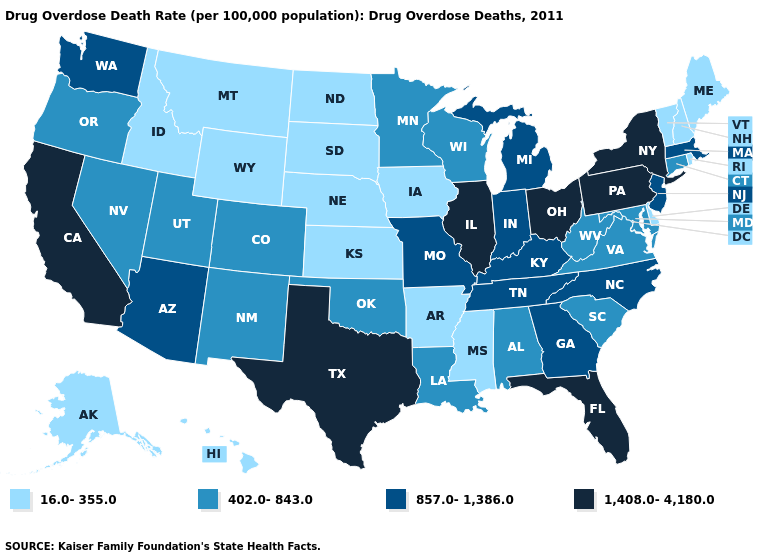What is the value of Minnesota?
Give a very brief answer. 402.0-843.0. Name the states that have a value in the range 1,408.0-4,180.0?
Be succinct. California, Florida, Illinois, New York, Ohio, Pennsylvania, Texas. Does Vermont have the lowest value in the USA?
Give a very brief answer. Yes. What is the value of North Dakota?
Keep it brief. 16.0-355.0. Which states have the lowest value in the South?
Be succinct. Arkansas, Delaware, Mississippi. Does Massachusetts have the lowest value in the Northeast?
Answer briefly. No. Name the states that have a value in the range 1,408.0-4,180.0?
Short answer required. California, Florida, Illinois, New York, Ohio, Pennsylvania, Texas. Which states have the lowest value in the West?
Be succinct. Alaska, Hawaii, Idaho, Montana, Wyoming. Does Illinois have the highest value in the USA?
Give a very brief answer. Yes. Name the states that have a value in the range 402.0-843.0?
Be succinct. Alabama, Colorado, Connecticut, Louisiana, Maryland, Minnesota, Nevada, New Mexico, Oklahoma, Oregon, South Carolina, Utah, Virginia, West Virginia, Wisconsin. What is the value of Wisconsin?
Concise answer only. 402.0-843.0. Among the states that border New Mexico , which have the highest value?
Concise answer only. Texas. Which states have the highest value in the USA?
Answer briefly. California, Florida, Illinois, New York, Ohio, Pennsylvania, Texas. Name the states that have a value in the range 857.0-1,386.0?
Keep it brief. Arizona, Georgia, Indiana, Kentucky, Massachusetts, Michigan, Missouri, New Jersey, North Carolina, Tennessee, Washington. 